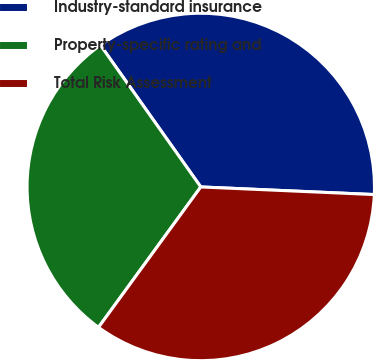Convert chart. <chart><loc_0><loc_0><loc_500><loc_500><pie_chart><fcel>Industry-standard insurance<fcel>Property-specific rating and<fcel>Total Risk Assessment<nl><fcel>35.5%<fcel>30.18%<fcel>34.32%<nl></chart> 